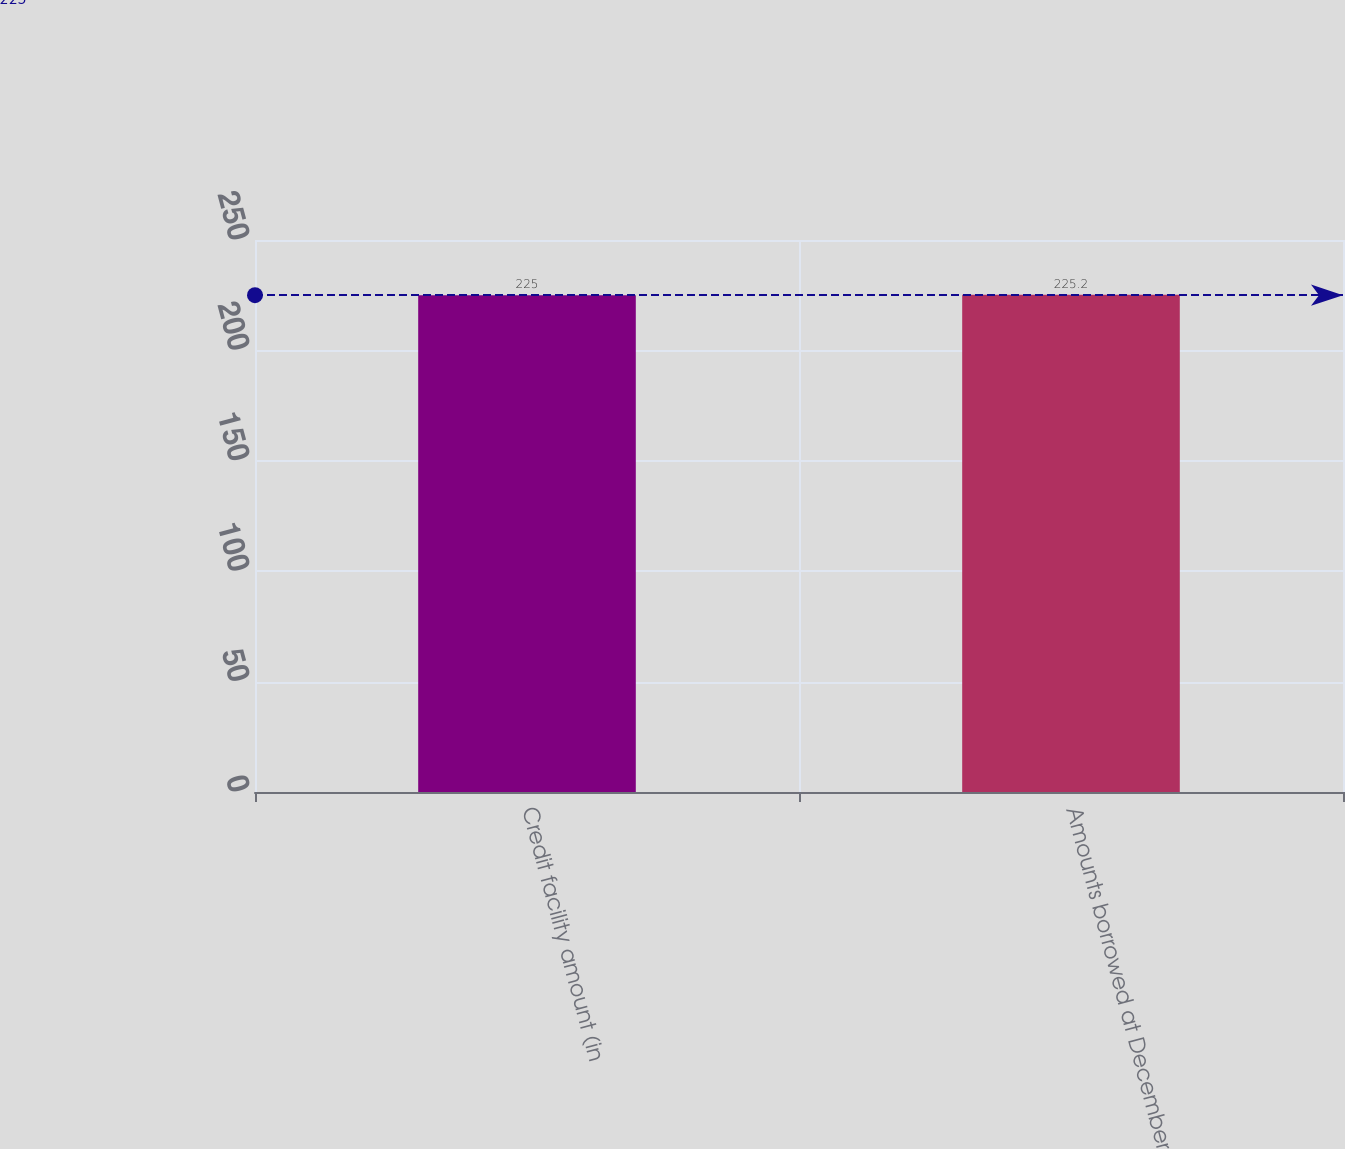<chart> <loc_0><loc_0><loc_500><loc_500><bar_chart><fcel>Credit facility amount (in<fcel>Amounts borrowed at December<nl><fcel>225<fcel>225.2<nl></chart> 